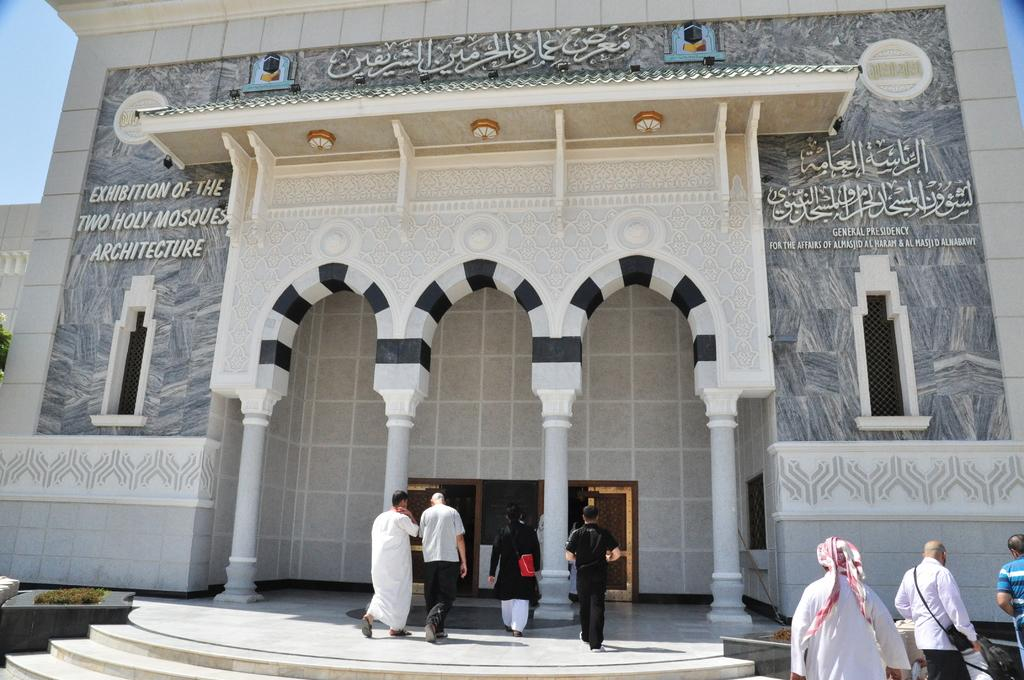What type of structure is present in the image? There is a building in the image. What architectural features can be seen on the building? The building has windows and pillars. What type of vegetation is visible in the image? There is grass in the image. What is the group of people doing in the image? Some people in the group are walking. What is visible in the background of the image? The sky is visible in the background of the image. Can you tell me how many keys are being used by the people in the image? There is no mention of keys in the image, so it is not possible to determine how many keys are being used. 